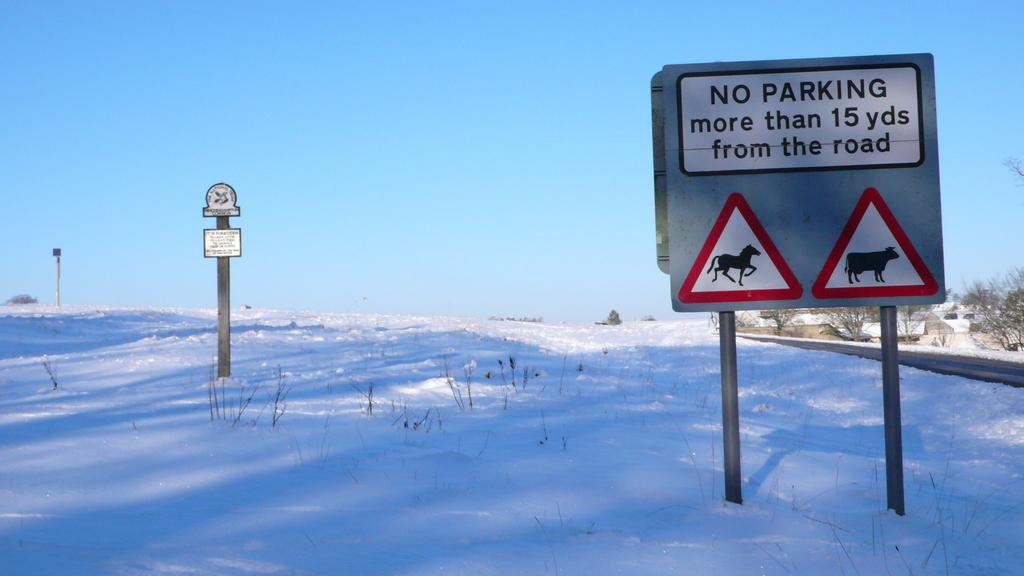<image>
Render a clear and concise summary of the photo. a sign that says no parking on it in snow 